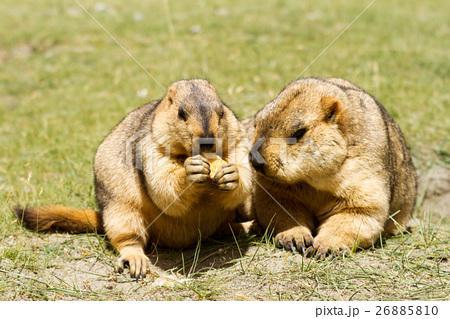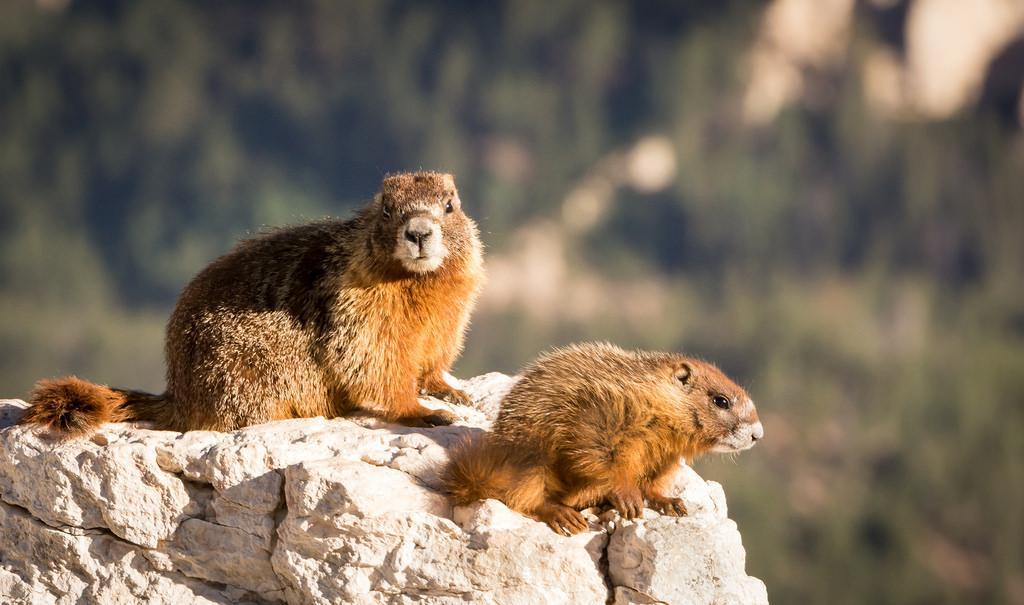The first image is the image on the left, the second image is the image on the right. For the images shown, is this caption "The animals in the image on the right are standing on their hind legs." true? Answer yes or no. No. 